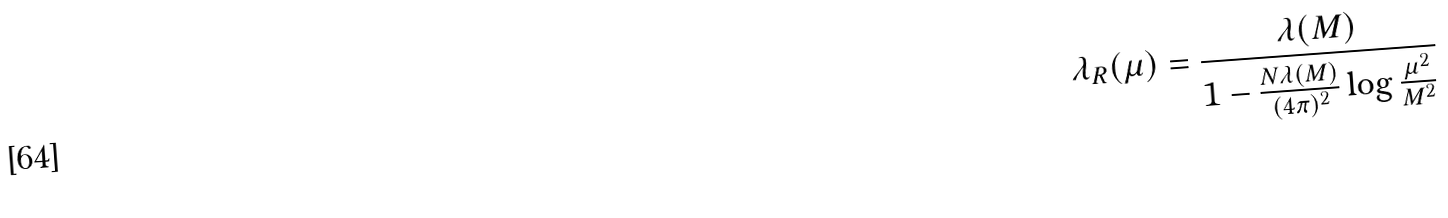<formula> <loc_0><loc_0><loc_500><loc_500>\lambda _ { R } ( \mu ) = \frac { \lambda ( M ) } { 1 - \frac { N \lambda ( M ) } { ( 4 \pi ) ^ { 2 } } \log \frac { \mu ^ { 2 } } { M ^ { 2 } } }</formula> 